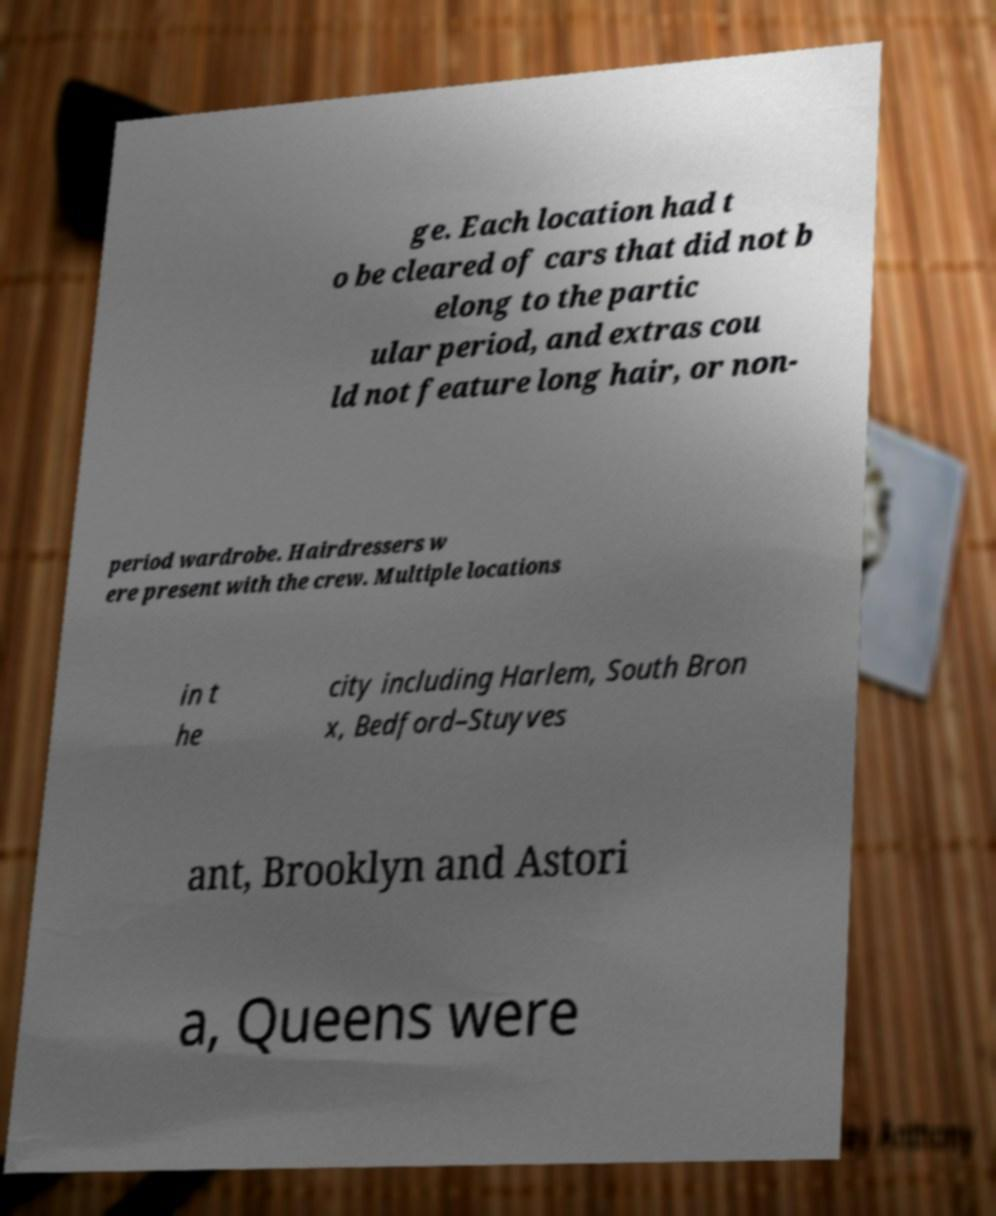Could you extract and type out the text from this image? ge. Each location had t o be cleared of cars that did not b elong to the partic ular period, and extras cou ld not feature long hair, or non- period wardrobe. Hairdressers w ere present with the crew. Multiple locations in t he city including Harlem, South Bron x, Bedford–Stuyves ant, Brooklyn and Astori a, Queens were 